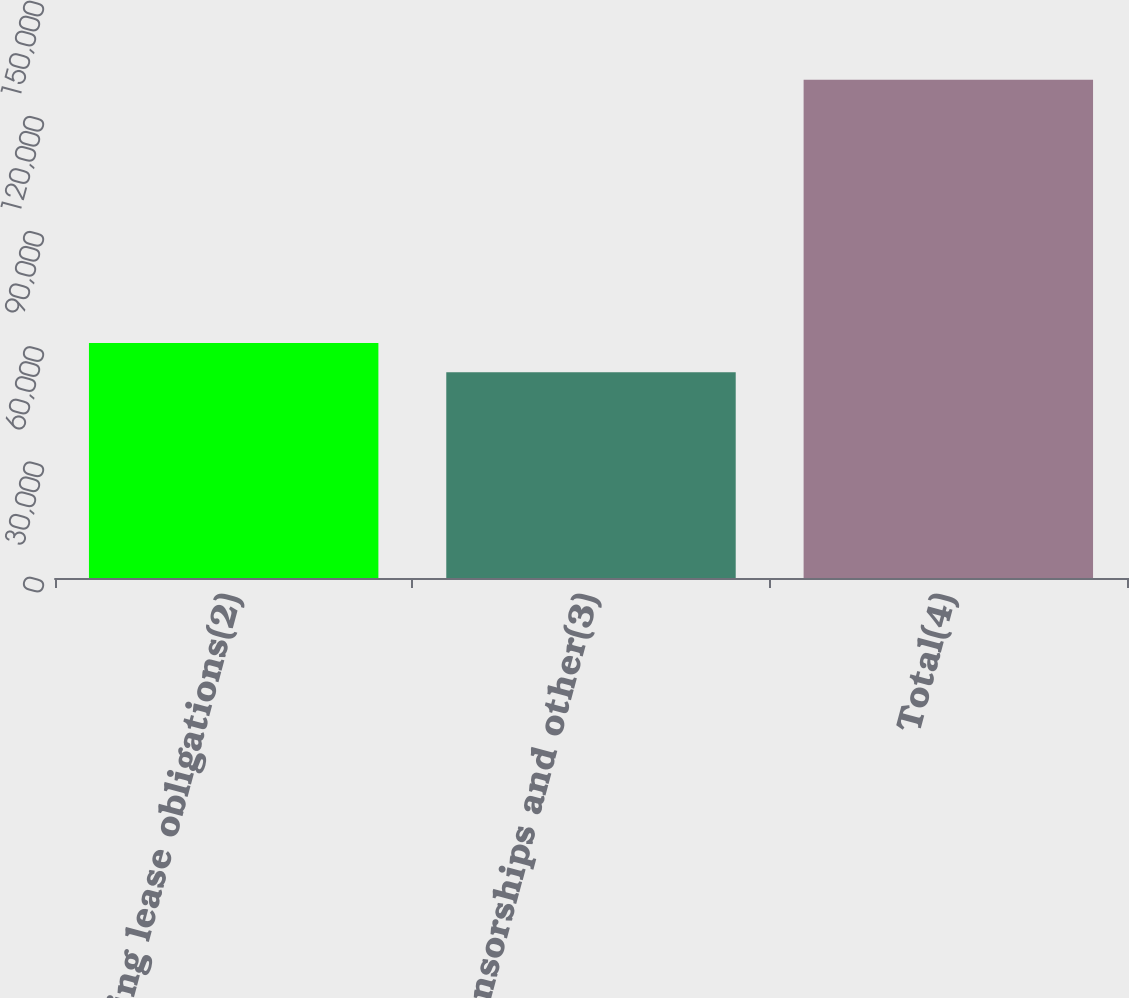Convert chart. <chart><loc_0><loc_0><loc_500><loc_500><bar_chart><fcel>Operating lease obligations(2)<fcel>Sponsorships and other(3)<fcel>Total(4)<nl><fcel>61200.4<fcel>53584<fcel>129748<nl></chart> 